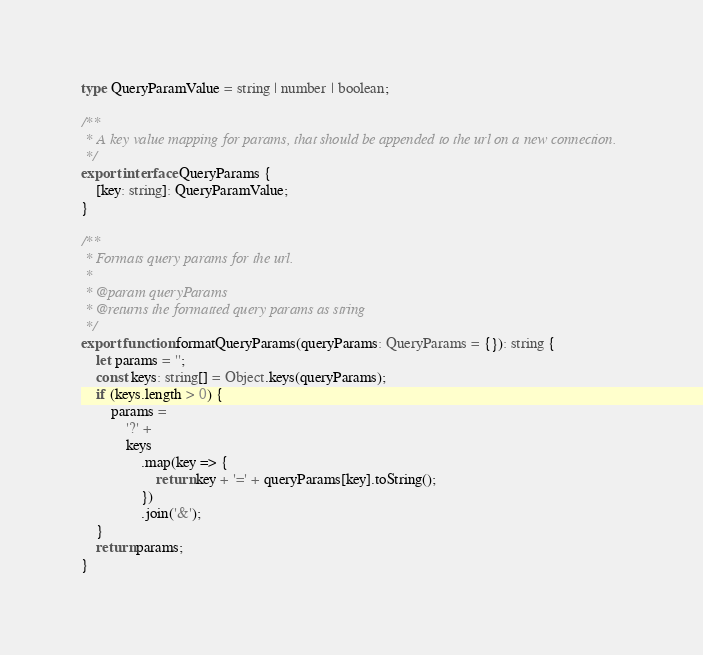Convert code to text. <code><loc_0><loc_0><loc_500><loc_500><_TypeScript_>type QueryParamValue = string | number | boolean;

/**
 * A key value mapping for params, that should be appended to the url on a new connection.
 */
export interface QueryParams {
    [key: string]: QueryParamValue;
}

/**
 * Formats query params for the url.
 *
 * @param queryParams
 * @returns the formatted query params as string
 */
export function formatQueryParams(queryParams: QueryParams = {}): string {
    let params = '';
    const keys: string[] = Object.keys(queryParams);
    if (keys.length > 0) {
        params =
            '?' +
            keys
                .map(key => {
                    return key + '=' + queryParams[key].toString();
                })
                .join('&');
    }
    return params;
}
</code> 